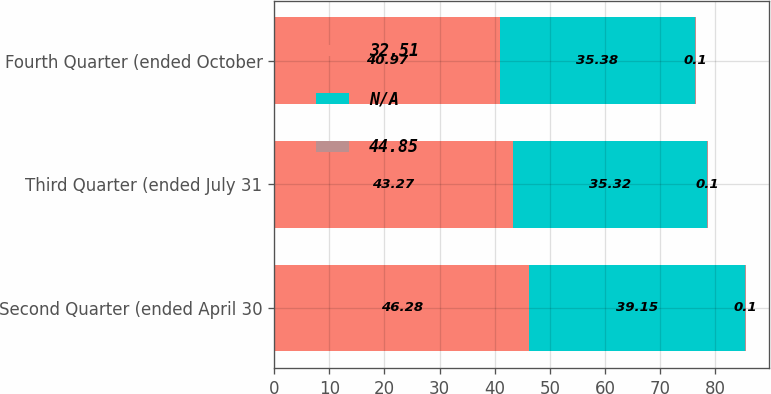Convert chart. <chart><loc_0><loc_0><loc_500><loc_500><stacked_bar_chart><ecel><fcel>Second Quarter (ended April 30<fcel>Third Quarter (ended July 31<fcel>Fourth Quarter (ended October<nl><fcel>32.51<fcel>46.28<fcel>43.27<fcel>40.97<nl><fcel>nan<fcel>39.15<fcel>35.32<fcel>35.38<nl><fcel>44.85<fcel>0.1<fcel>0.1<fcel>0.1<nl></chart> 